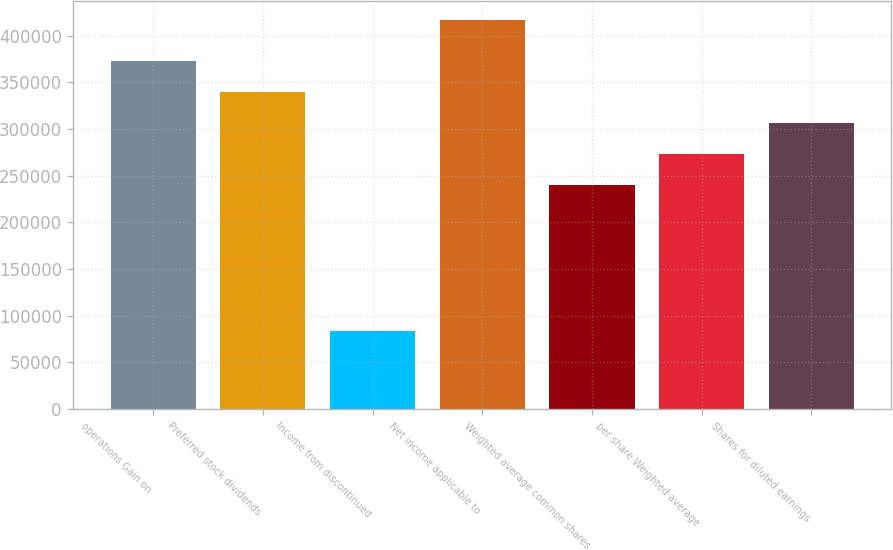<chart> <loc_0><loc_0><loc_500><loc_500><bar_chart><fcel>operations Gain on<fcel>Preferred stock dividends<fcel>Income from discontinued<fcel>Net income applicable to<fcel>Weighted average common shares<fcel>per share Weighted average<fcel>Shares for diluted earnings<nl><fcel>372949<fcel>339600<fcel>83128<fcel>416621<fcel>239552<fcel>272901<fcel>306251<nl></chart> 